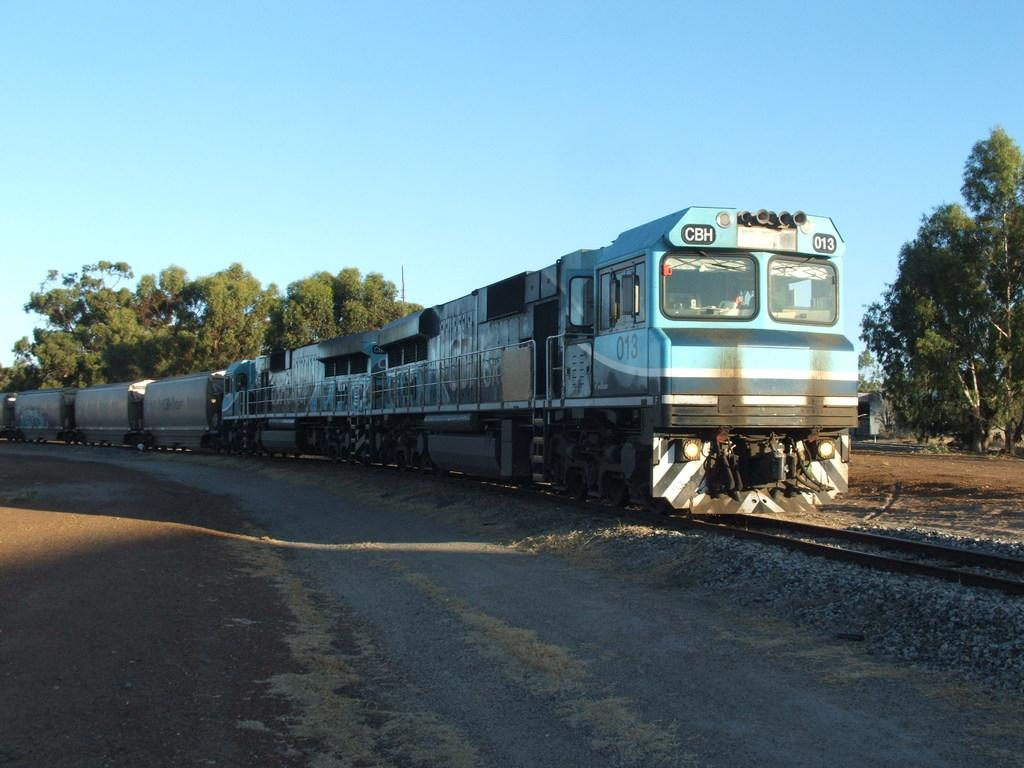What is the main subject in the center of the image? There is a train in the center of the image. What is the train situated on? The train is on a railway track. What can be seen on the left side of the image? There is a road on the left side of the image. What is visible in the background of the image? There are trees and the sky visible in the background of the image. What type of animal can be seen shopping at the market in the image? There is no market or animal present in the image; it features a train on a railway track with a road, trees, and sky in the background. 